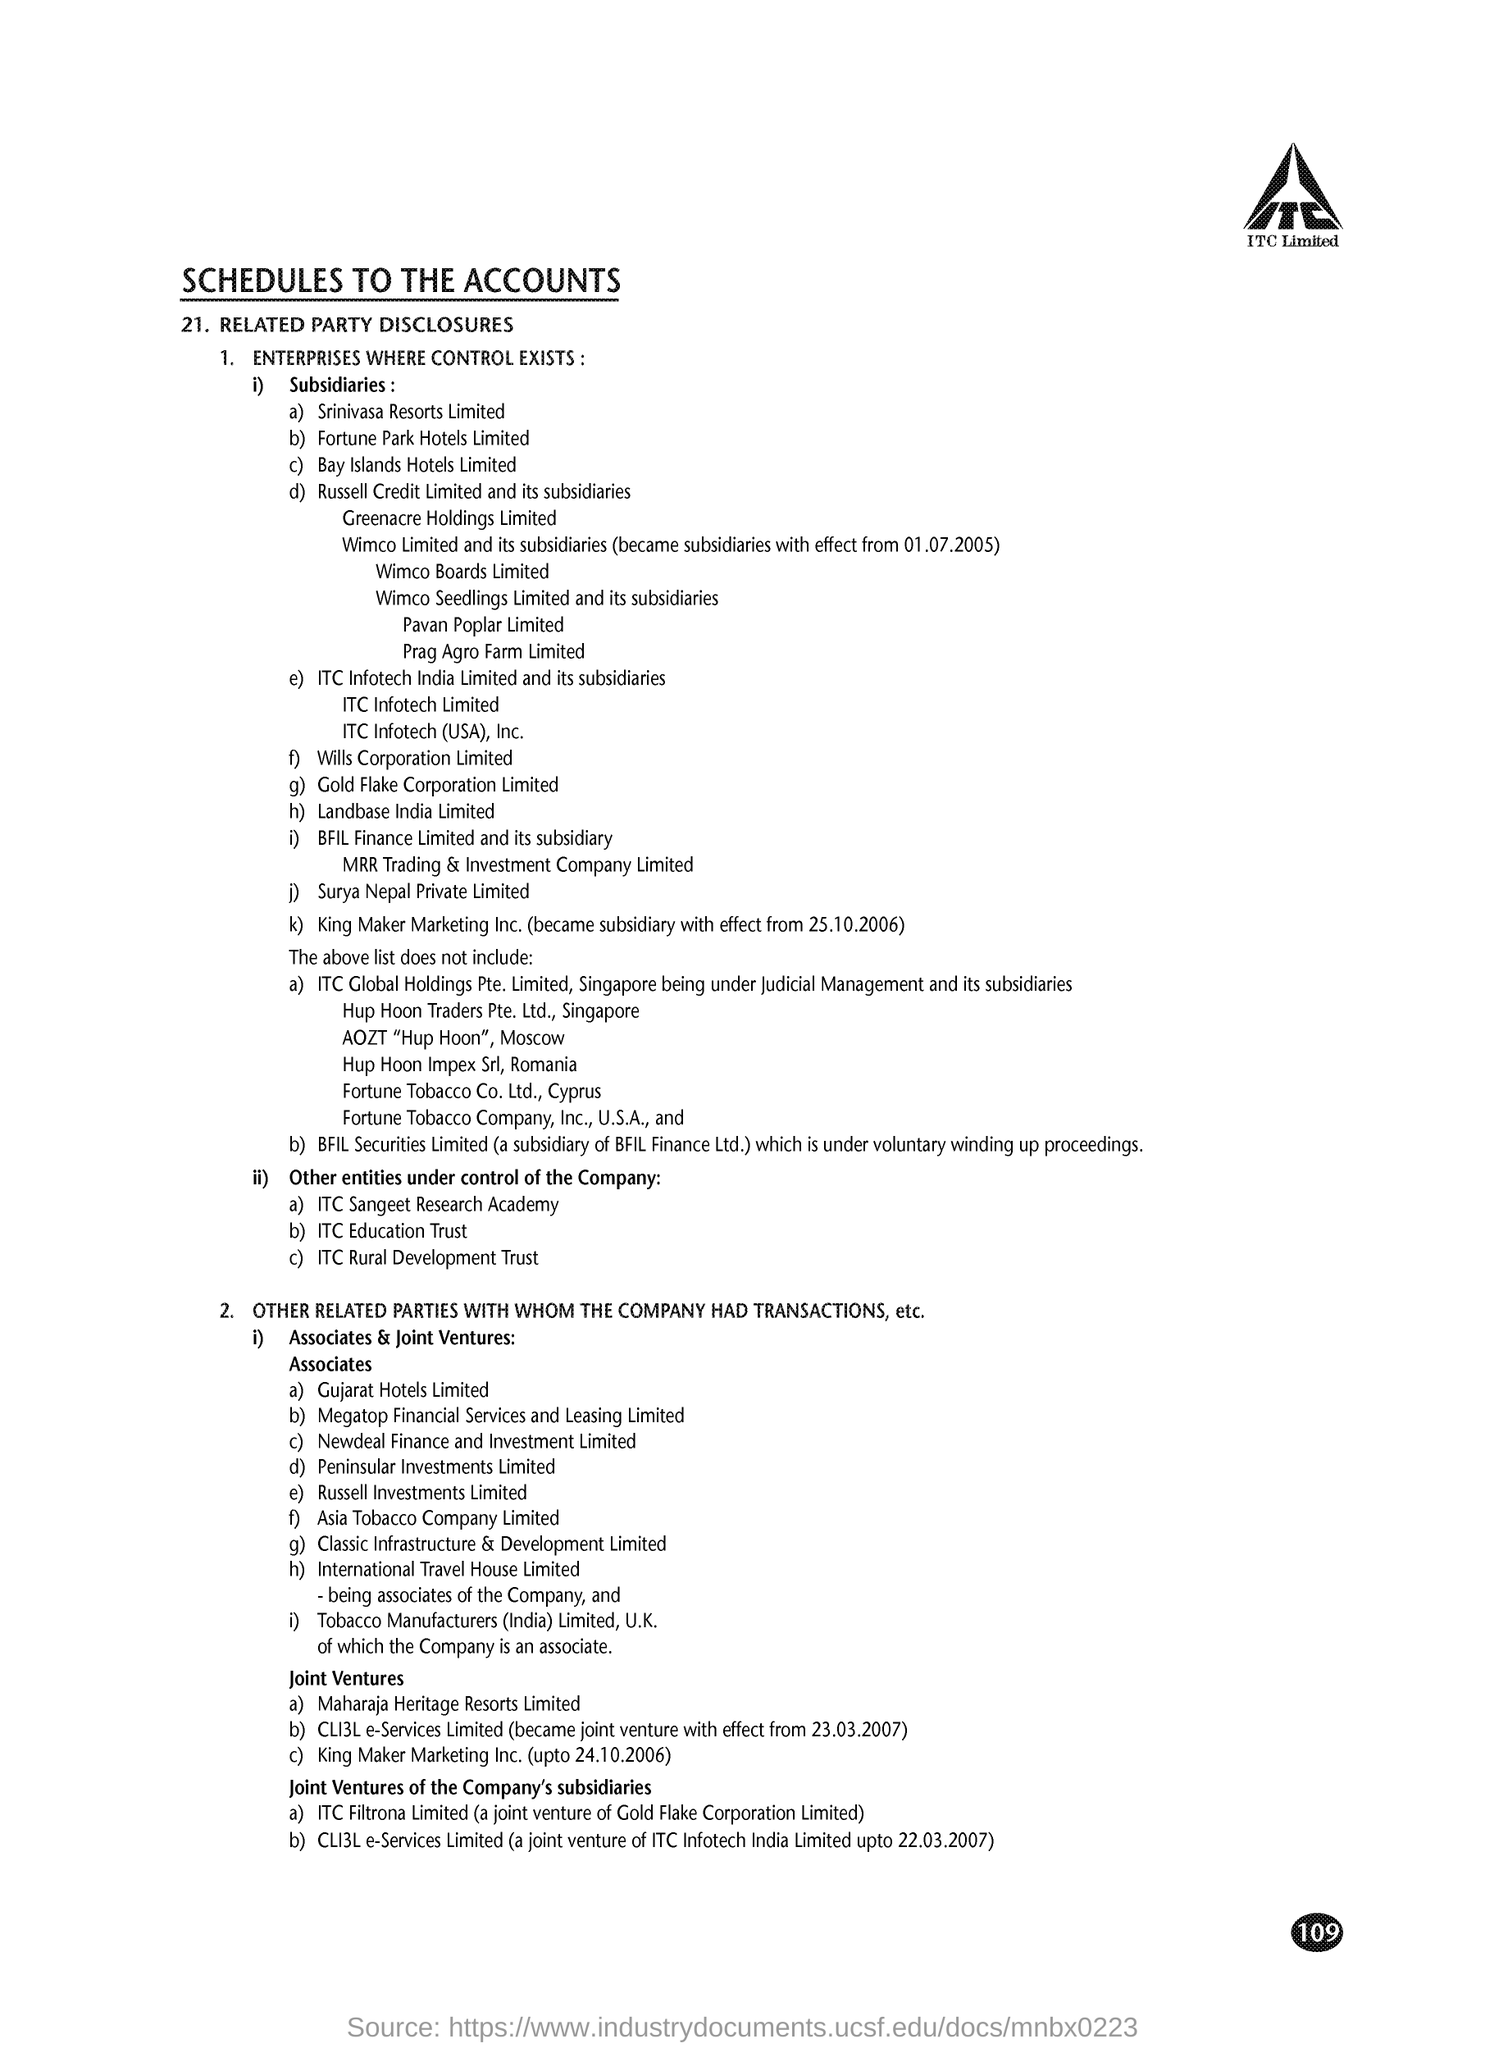Which company's name is at the top of the page?
Provide a succinct answer. ITC. What is the document title?
Offer a very short reply. Schedules to the accounts. What is point number 21 in the document?
Offer a terse response. Related Party Disclosures. 